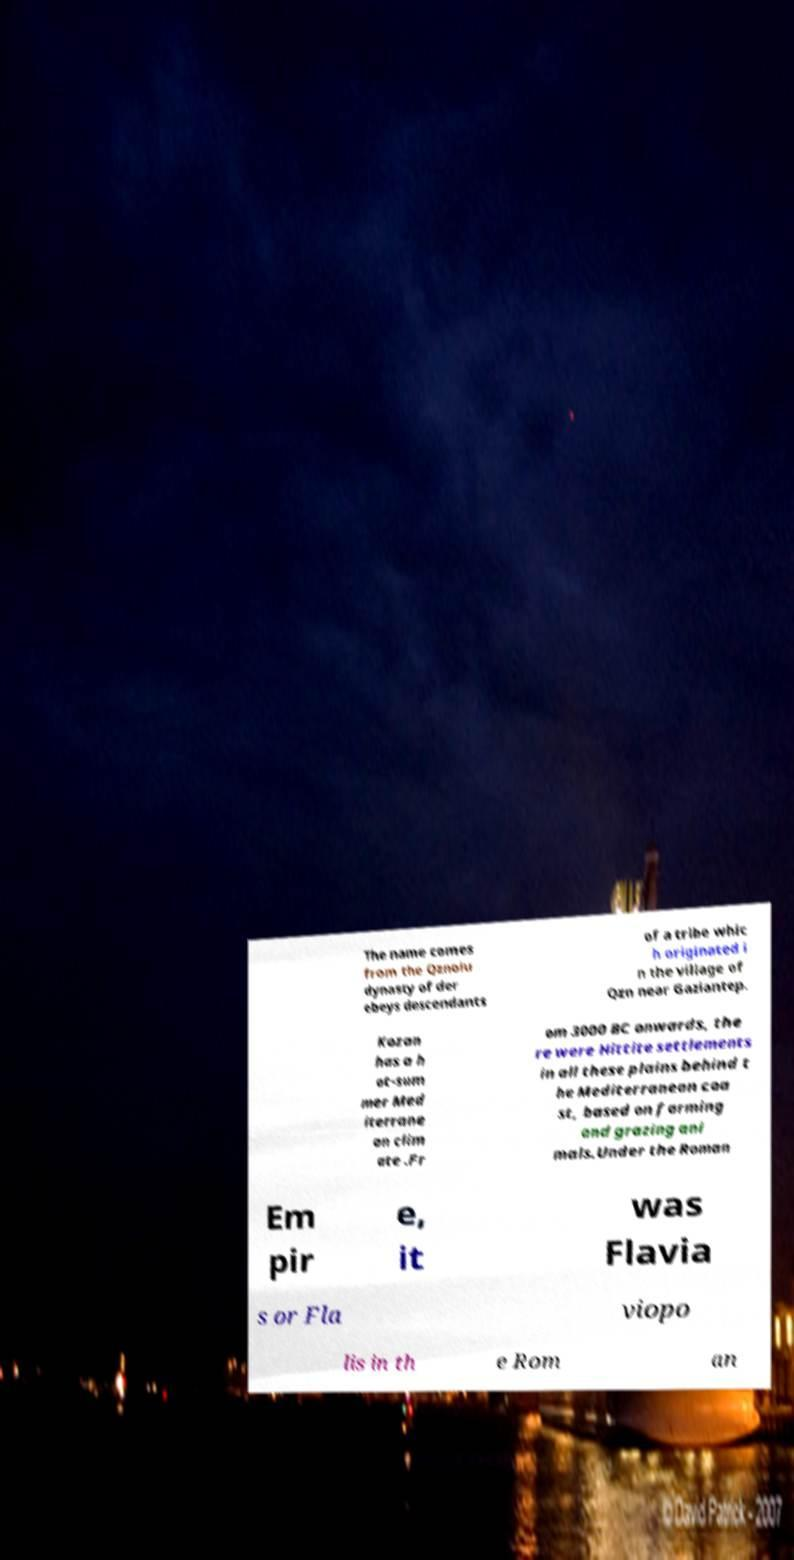Could you extract and type out the text from this image? The name comes from the Qznolu dynasty of der ebeys descendants of a tribe whic h originated i n the village of Qzn near Gaziantep. Kozan has a h ot-sum mer Med iterrane an clim ate .Fr om 3000 BC onwards, the re were Hittite settlements in all these plains behind t he Mediterranean coa st, based on farming and grazing ani mals.Under the Roman Em pir e, it was Flavia s or Fla viopo lis in th e Rom an 